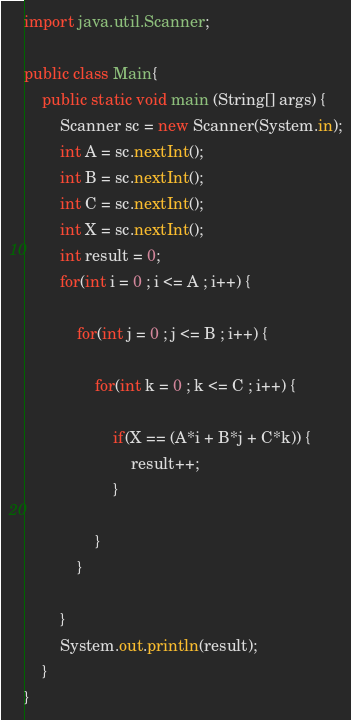<code> <loc_0><loc_0><loc_500><loc_500><_Java_>import java.util.Scanner;

public class Main{
	public static void main (String[] args) {
		Scanner sc = new Scanner(System.in);
		int A = sc.nextInt();
		int B = sc.nextInt();
		int C = sc.nextInt();
		int X = sc.nextInt();
		int result = 0;
		for(int i = 0 ; i <= A ; i++) {
			
			for(int j = 0 ; j <= B ; i++) {
				
				for(int k = 0 ; k <= C ; i++) {
					
					if(X == (A*i + B*j + C*k)) {
						result++;
					}
					
				}
			}
			
		}
		System.out.println(result);
	}
}</code> 